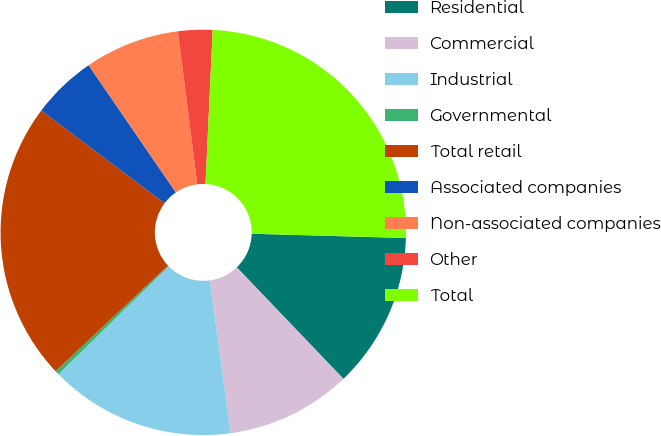<chart> <loc_0><loc_0><loc_500><loc_500><pie_chart><fcel>Residential<fcel>Commercial<fcel>Industrial<fcel>Governmental<fcel>Total retail<fcel>Associated companies<fcel>Non-associated companies<fcel>Other<fcel>Total<nl><fcel>12.41%<fcel>9.99%<fcel>14.83%<fcel>0.32%<fcel>22.28%<fcel>5.16%<fcel>7.57%<fcel>2.74%<fcel>24.7%<nl></chart> 